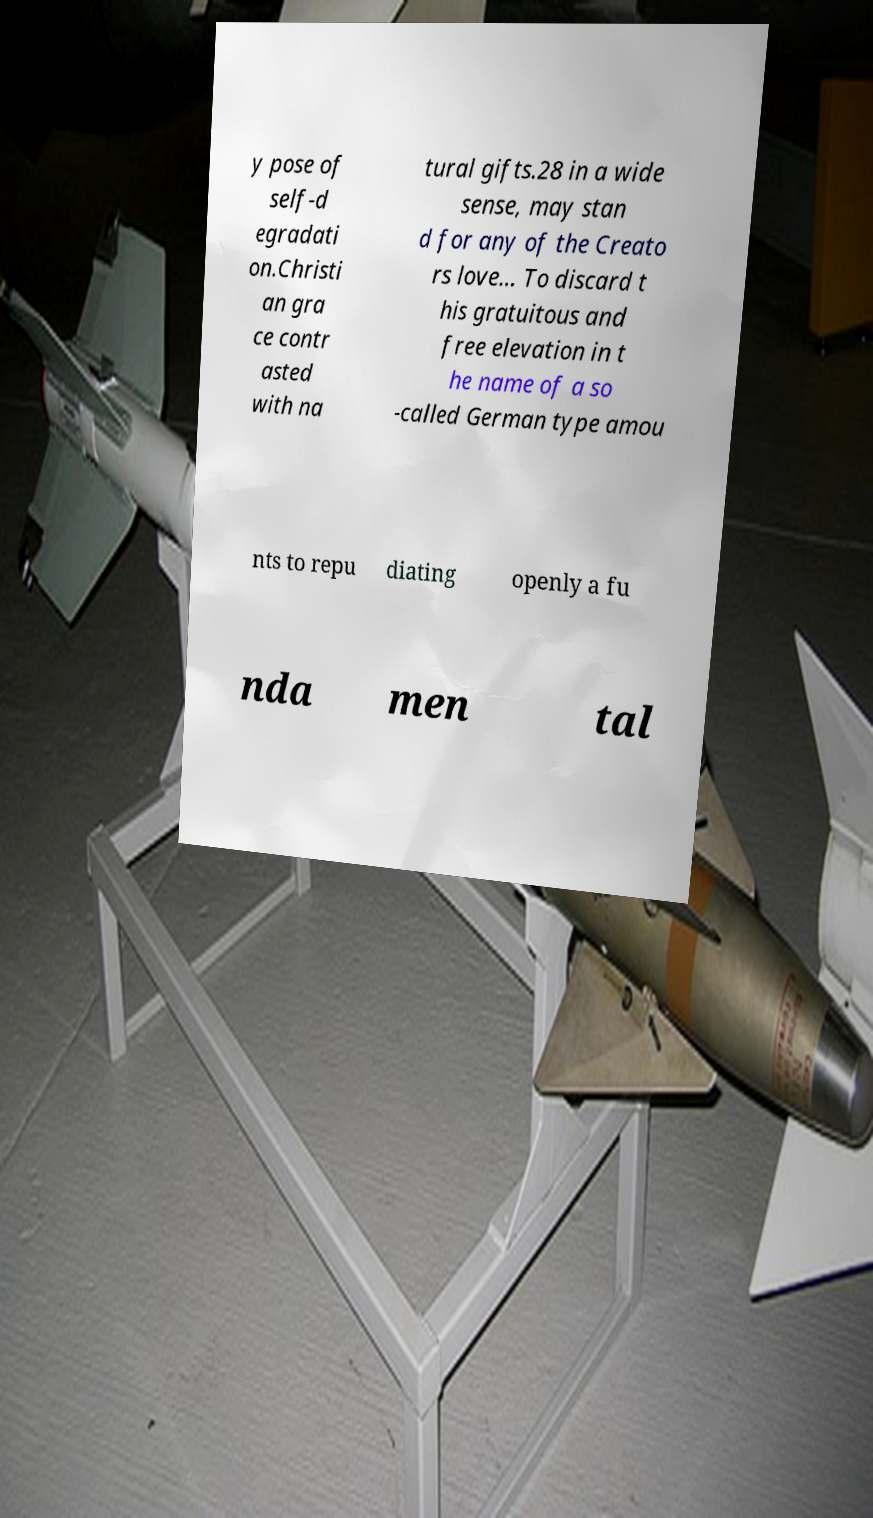There's text embedded in this image that I need extracted. Can you transcribe it verbatim? y pose of self-d egradati on.Christi an gra ce contr asted with na tural gifts.28 in a wide sense, may stan d for any of the Creato rs love... To discard t his gratuitous and free elevation in t he name of a so -called German type amou nts to repu diating openly a fu nda men tal 